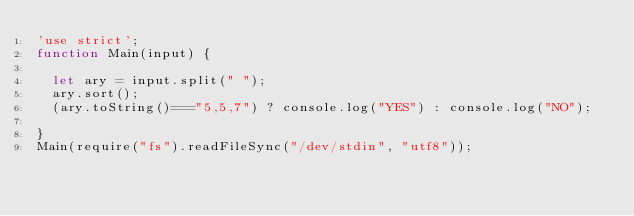Convert code to text. <code><loc_0><loc_0><loc_500><loc_500><_JavaScript_>'use strict';
function Main(input) {

  let ary = input.split(" ");
  ary.sort();
  (ary.toString()==="5,5,7") ? console.log("YES") : console.log("NO");

}
Main(require("fs").readFileSync("/dev/stdin", "utf8"));</code> 